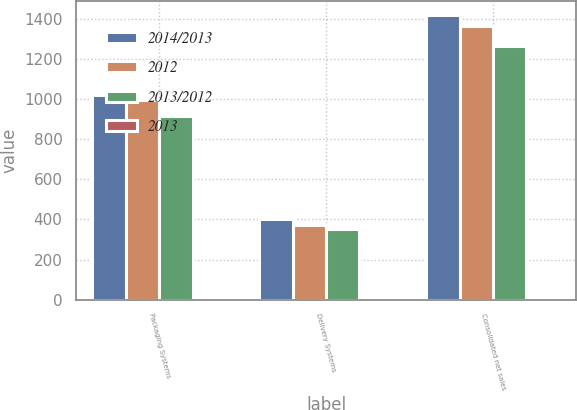<chart> <loc_0><loc_0><loc_500><loc_500><stacked_bar_chart><ecel><fcel>Packaging Systems<fcel>Delivery Systems<fcel>Consolidated net sales<nl><fcel>2014/2013<fcel>1019.7<fcel>402.5<fcel>1421.4<nl><fcel>2012<fcel>996<fcel>374.1<fcel>1368.4<nl><fcel>2013/2012<fcel>915.1<fcel>352.1<fcel>1266.4<nl><fcel>2013<fcel>2.4<fcel>7.6<fcel>3.9<nl></chart> 